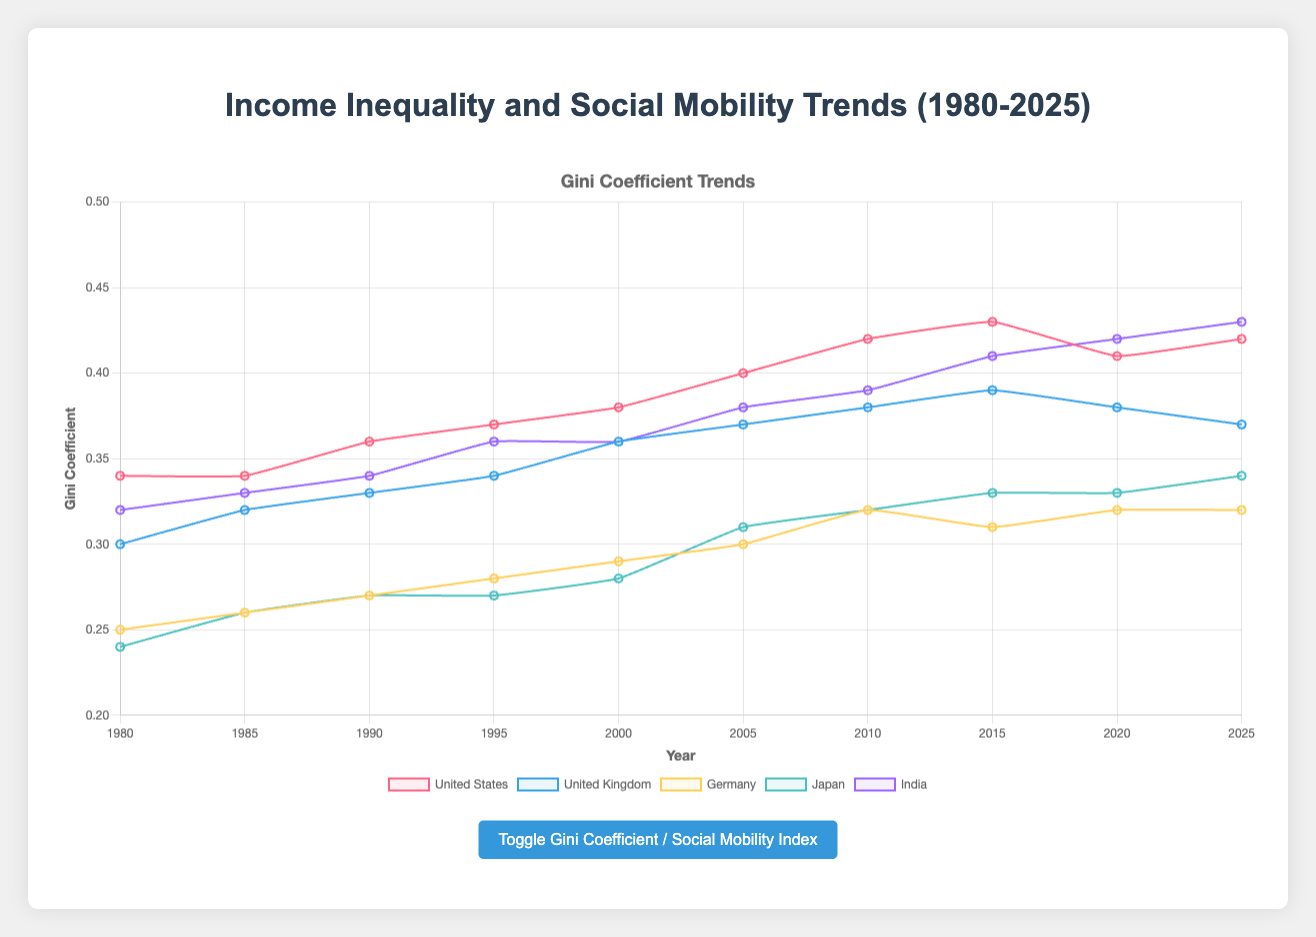What country has the highest Gini Coefficient in 2020? By observing the trend of Gini Coefficient for 2020, we can see that India has the highest value among all countries.
Answer: India How did the Social Mobility Index in Germany change from 1980 to 2025? In 1980, Germany's Social Mobility Index was 70, and it decreased gradually to 60 by 2025.
Answer: Decreased from 70 to 60 Compare the Gini Coefficient trends of Japan and United Kingdom between 1980 and 2025. Which country shows a higher increase? In 1980, Japan's Gini Coefficient was 0.24 which increased to 0.34 by 2025, showing an increase of 0.10. The United Kingdom's Gini Coefficient increased from 0.30 to 0.37, an increase of 0.07. Thus, Japan shows a higher increase.
Answer: Japan Which country has the least variation in its Gini Coefficient between 1980 and 2025? By visual inspection, Germany's Gini Coefficient shows smaller variations compared to the other countries, ranging from 0.25 to 0.32.
Answer: Germany What's the difference in the Social Mobility Index between the United States and India in 2025? In 2025, the Social Mobility Index of the United States is 54, and for India, it is 35. The difference is 54 - 35 = 19.
Answer: 19 Compare the social mobility trends of the United States and Japan. Which country shows a steeper decline? The United States' Social Mobility Index decreases from 65 in 1980 to 54 in 2025, a decline of 11. Japan's index decreases from 75 in 1980 to 62 in 2025, a decline of 13. Thus, Japan shows a steeper decline.
Answer: Japan What is the average Gini Coefficient for India from 1980 to 2025? Sum India's Gini Coefficients (0.32, 0.33, 0.34, 0.36, 0.36, 0.38, 0.39, 0.41, 0.42, 0.43) = 3.74. The average is 3.74 / 10 = 0.374.
Answer: 0.374 Which country has the highest Gini Coefficient and the lowest Social Mobility Index in 2025? In 2025, India has the highest Gini Coefficient (0.43) and the lowest Social Mobility Index (35).
Answer: India What is the percentage change in the Social Mobility Index for the United Kingdom from 1980 to 2025? The Social Mobility Index decreases from 60 in 1980 to 50 in 2025. The percentage change is ((60 - 50) / 60) * 100 = 16.67%.
Answer: 16.67% Which country maintains its rank with the highest Social Mobility Index throughout the entire period from 1980 to 2025? By visual inspection, Japan consistently has the highest Social Mobility Index in all listed years from 1980 to 2025.
Answer: Japan 